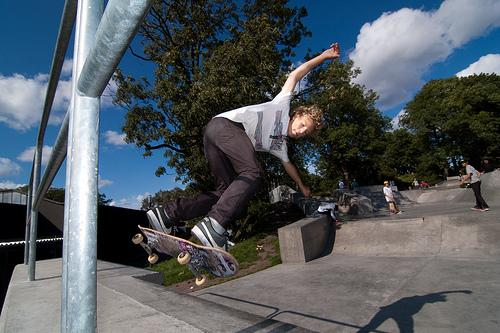List down all the color descriptions mentioned in the image information. Grey shirt, black jeans, tennis shoes, blonde hair, green forest trees, brilliant blue sky, white puffy clouds, dark pants, white shirt, black pants, white socks, white and black shoes, and red shirt. Provide a description of the scene taking place at the skateboard park. A blonde boy is doing a skateboarding trick in the air at an outdoor cement park, with spectators nearby and a surrounding environment of green trees, blue sky with clouds, and a metal fence. Identify any elements in the image that might demonstrate the quality of the skateboard itself. The skateboard appears to have a torn up underside and has lots of pictures beneath the board, with white wheels indicating some level of wear or artistically unique design. In your opinion, is there anything unusual or worth mentioning about the boy's appearance? Not wearing a helmet while skateboarding is unusual and potentially dangerous; also, the boy has short blond curly hair flying in the breeze, making it noticeable. How many total objects are visible in the image information, including the primary subject? There are 39 objects visible, ranging from the main subject to numerous smaller details like clouds, trees, shadows, and people. Is there any implication of movement or dynamism in the image, and if so, what suggests it? Yes, there's an implication of movement, as the boy is completely in the air while performing a trick on the skateboard, and his arms are out for balance, with his hair flying in the breeze. What is the primary focus of the image, and can you describe their current action? The main focus is a boy on a skateboard, who is performing a trick while being completely in the air with arms out for balance. What is the emotion conveyed in the image based on the object interactions and overall scene? The image conveys excitement, as the boy is performing a trick on a skateboard, and spectators are present to watch him. Count the number of people mentioned in the image information and describe what they are wearing. There are 2 people: one boy wearing a grey shirt with gray stripes, black jeans, tennis shoes, and no helmet; another person wears a red shirt, has dark pants and a white shirt. What objects can be found in the picture apart from the main subject? A skateboard with torn up underside and white wheels, a shadow of the boy and skateboard on the ground, a patch of grass, a metal fence, green trees, blue sky with puffy clouds, and other spectators. 